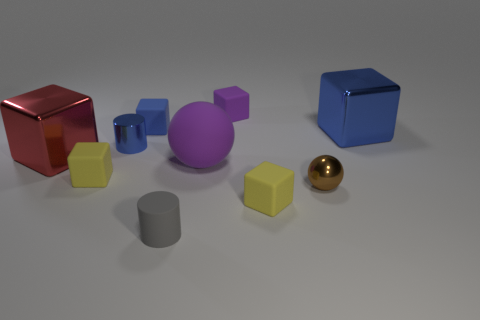Is there a sphere of the same color as the matte cylinder?
Your response must be concise. No. What shape is the blue shiny object that is the same size as the gray thing?
Make the answer very short. Cylinder. Is the number of big cubes less than the number of tiny blue metal things?
Your answer should be very brief. No. How many blue cubes are the same size as the blue matte object?
Make the answer very short. 0. The small matte object that is the same color as the matte sphere is what shape?
Offer a very short reply. Cube. What is the material of the purple block?
Provide a succinct answer. Rubber. There is a yellow rubber block that is in front of the brown sphere; how big is it?
Give a very brief answer. Small. What number of tiny blue matte things are the same shape as the big rubber object?
Give a very brief answer. 0. What shape is the large purple thing that is the same material as the tiny purple block?
Offer a very short reply. Sphere. How many purple things are either tiny blocks or large matte spheres?
Provide a succinct answer. 2. 